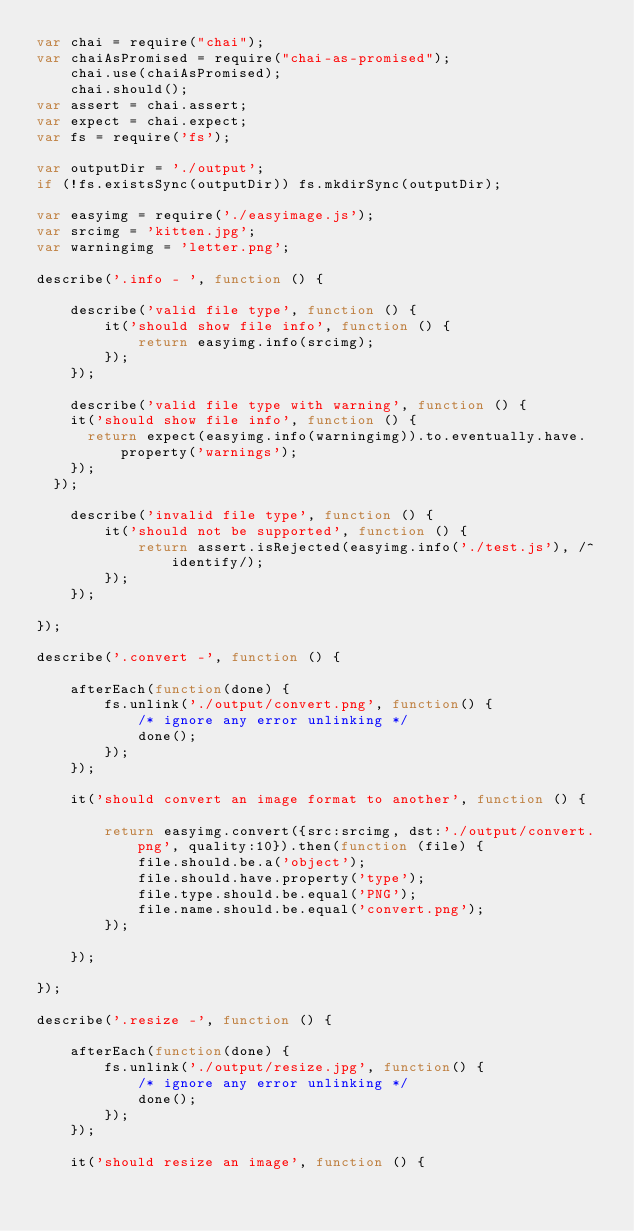<code> <loc_0><loc_0><loc_500><loc_500><_JavaScript_>var chai = require("chai");
var chaiAsPromised = require("chai-as-promised");
    chai.use(chaiAsPromised);
    chai.should();
var assert = chai.assert;
var expect = chai.expect;
var fs = require('fs');

var outputDir = './output';
if (!fs.existsSync(outputDir)) fs.mkdirSync(outputDir);

var easyimg = require('./easyimage.js');
var srcimg = 'kitten.jpg';
var warningimg = 'letter.png';

describe('.info - ', function () {

    describe('valid file type', function () {
        it('should show file info', function () {
            return easyimg.info(srcimg);
        });
    });

    describe('valid file type with warning', function () {
		it('should show file info', function () {
			return expect(easyimg.info(warningimg)).to.eventually.have.property('warnings');
		});
	});

    describe('invalid file type', function () {
        it('should not be supported', function () {
            return assert.isRejected(easyimg.info('./test.js'), /^identify/);
        });
    });

});

describe('.convert -', function () {

    afterEach(function(done) {
        fs.unlink('./output/convert.png', function() {
            /* ignore any error unlinking */
            done();
        });
    });

    it('should convert an image format to another', function () {

        return easyimg.convert({src:srcimg, dst:'./output/convert.png', quality:10}).then(function (file) {
            file.should.be.a('object');
            file.should.have.property('type');
            file.type.should.be.equal('PNG');
            file.name.should.be.equal('convert.png');
        });

    });

});

describe('.resize -', function () {

    afterEach(function(done) {
        fs.unlink('./output/resize.jpg', function() {
            /* ignore any error unlinking */
            done();
        });
    });

    it('should resize an image', function () {
</code> 